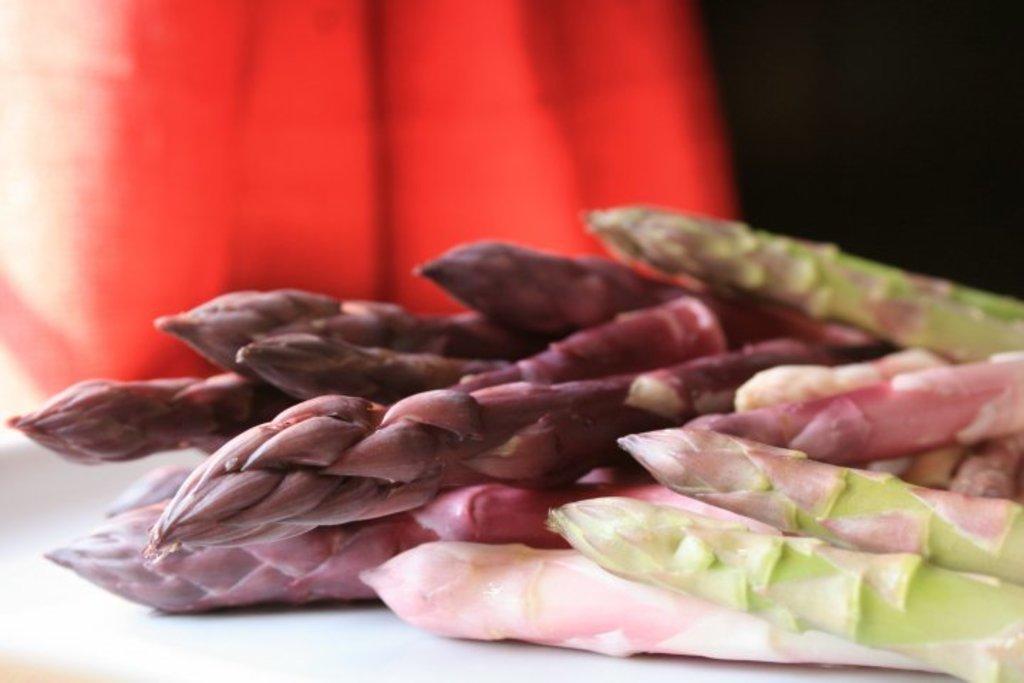Describe this image in one or two sentences. In this image I can see lotus flowers and other stems on the table. In the background I can see red and black color. This image is taken may be in a room. 